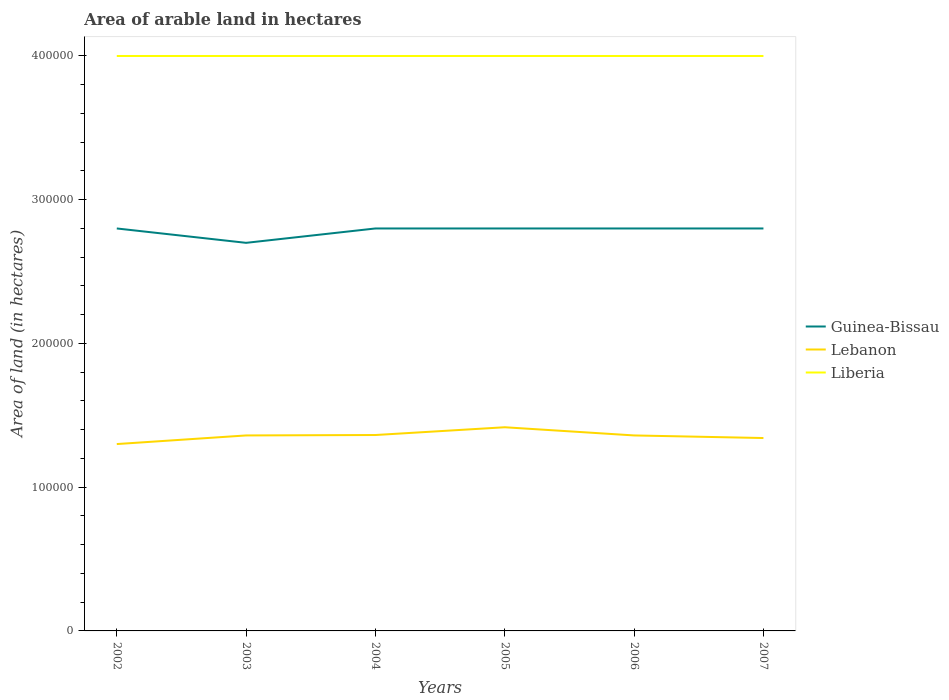How many different coloured lines are there?
Give a very brief answer. 3. Does the line corresponding to Lebanon intersect with the line corresponding to Liberia?
Make the answer very short. No. Across all years, what is the maximum total arable land in Lebanon?
Provide a succinct answer. 1.30e+05. What is the total total arable land in Lebanon in the graph?
Your answer should be very brief. -300. What is the difference between the highest and the second highest total arable land in Lebanon?
Your response must be concise. 1.17e+04. Where does the legend appear in the graph?
Ensure brevity in your answer.  Center right. What is the title of the graph?
Give a very brief answer. Area of arable land in hectares. What is the label or title of the Y-axis?
Provide a succinct answer. Area of land (in hectares). What is the Area of land (in hectares) in Guinea-Bissau in 2002?
Provide a short and direct response. 2.80e+05. What is the Area of land (in hectares) of Lebanon in 2002?
Provide a short and direct response. 1.30e+05. What is the Area of land (in hectares) of Lebanon in 2003?
Offer a terse response. 1.36e+05. What is the Area of land (in hectares) in Lebanon in 2004?
Your response must be concise. 1.36e+05. What is the Area of land (in hectares) in Guinea-Bissau in 2005?
Provide a short and direct response. 2.80e+05. What is the Area of land (in hectares) in Lebanon in 2005?
Provide a succinct answer. 1.42e+05. What is the Area of land (in hectares) of Liberia in 2005?
Offer a very short reply. 4.00e+05. What is the Area of land (in hectares) of Guinea-Bissau in 2006?
Make the answer very short. 2.80e+05. What is the Area of land (in hectares) in Lebanon in 2006?
Your answer should be compact. 1.36e+05. What is the Area of land (in hectares) in Lebanon in 2007?
Your answer should be compact. 1.34e+05. Across all years, what is the maximum Area of land (in hectares) of Lebanon?
Your response must be concise. 1.42e+05. Across all years, what is the maximum Area of land (in hectares) of Liberia?
Your answer should be very brief. 4.00e+05. Across all years, what is the minimum Area of land (in hectares) in Lebanon?
Give a very brief answer. 1.30e+05. What is the total Area of land (in hectares) of Guinea-Bissau in the graph?
Your answer should be very brief. 1.67e+06. What is the total Area of land (in hectares) in Lebanon in the graph?
Ensure brevity in your answer.  8.14e+05. What is the total Area of land (in hectares) of Liberia in the graph?
Provide a short and direct response. 2.40e+06. What is the difference between the Area of land (in hectares) of Guinea-Bissau in 2002 and that in 2003?
Your answer should be compact. 10000. What is the difference between the Area of land (in hectares) in Lebanon in 2002 and that in 2003?
Make the answer very short. -6000. What is the difference between the Area of land (in hectares) of Lebanon in 2002 and that in 2004?
Your response must be concise. -6300. What is the difference between the Area of land (in hectares) of Lebanon in 2002 and that in 2005?
Your answer should be very brief. -1.17e+04. What is the difference between the Area of land (in hectares) in Guinea-Bissau in 2002 and that in 2006?
Offer a terse response. 0. What is the difference between the Area of land (in hectares) in Lebanon in 2002 and that in 2006?
Your response must be concise. -6000. What is the difference between the Area of land (in hectares) in Guinea-Bissau in 2002 and that in 2007?
Your answer should be compact. 0. What is the difference between the Area of land (in hectares) in Lebanon in 2002 and that in 2007?
Provide a succinct answer. -4200. What is the difference between the Area of land (in hectares) in Liberia in 2002 and that in 2007?
Provide a short and direct response. 0. What is the difference between the Area of land (in hectares) of Guinea-Bissau in 2003 and that in 2004?
Make the answer very short. -10000. What is the difference between the Area of land (in hectares) of Lebanon in 2003 and that in 2004?
Your answer should be very brief. -300. What is the difference between the Area of land (in hectares) of Guinea-Bissau in 2003 and that in 2005?
Your answer should be very brief. -10000. What is the difference between the Area of land (in hectares) in Lebanon in 2003 and that in 2005?
Ensure brevity in your answer.  -5700. What is the difference between the Area of land (in hectares) in Liberia in 2003 and that in 2005?
Provide a short and direct response. 0. What is the difference between the Area of land (in hectares) of Lebanon in 2003 and that in 2007?
Give a very brief answer. 1800. What is the difference between the Area of land (in hectares) of Lebanon in 2004 and that in 2005?
Provide a succinct answer. -5400. What is the difference between the Area of land (in hectares) in Guinea-Bissau in 2004 and that in 2006?
Provide a succinct answer. 0. What is the difference between the Area of land (in hectares) in Lebanon in 2004 and that in 2006?
Your answer should be very brief. 300. What is the difference between the Area of land (in hectares) in Liberia in 2004 and that in 2006?
Keep it short and to the point. 0. What is the difference between the Area of land (in hectares) in Lebanon in 2004 and that in 2007?
Provide a short and direct response. 2100. What is the difference between the Area of land (in hectares) of Liberia in 2004 and that in 2007?
Your answer should be compact. 0. What is the difference between the Area of land (in hectares) in Guinea-Bissau in 2005 and that in 2006?
Offer a very short reply. 0. What is the difference between the Area of land (in hectares) in Lebanon in 2005 and that in 2006?
Keep it short and to the point. 5700. What is the difference between the Area of land (in hectares) in Liberia in 2005 and that in 2006?
Give a very brief answer. 0. What is the difference between the Area of land (in hectares) in Lebanon in 2005 and that in 2007?
Ensure brevity in your answer.  7500. What is the difference between the Area of land (in hectares) in Liberia in 2005 and that in 2007?
Your answer should be very brief. 0. What is the difference between the Area of land (in hectares) of Guinea-Bissau in 2006 and that in 2007?
Keep it short and to the point. 0. What is the difference between the Area of land (in hectares) of Lebanon in 2006 and that in 2007?
Provide a short and direct response. 1800. What is the difference between the Area of land (in hectares) in Guinea-Bissau in 2002 and the Area of land (in hectares) in Lebanon in 2003?
Your answer should be very brief. 1.44e+05. What is the difference between the Area of land (in hectares) in Guinea-Bissau in 2002 and the Area of land (in hectares) in Lebanon in 2004?
Your answer should be very brief. 1.44e+05. What is the difference between the Area of land (in hectares) of Guinea-Bissau in 2002 and the Area of land (in hectares) of Liberia in 2004?
Give a very brief answer. -1.20e+05. What is the difference between the Area of land (in hectares) of Guinea-Bissau in 2002 and the Area of land (in hectares) of Lebanon in 2005?
Your response must be concise. 1.38e+05. What is the difference between the Area of land (in hectares) of Lebanon in 2002 and the Area of land (in hectares) of Liberia in 2005?
Keep it short and to the point. -2.70e+05. What is the difference between the Area of land (in hectares) of Guinea-Bissau in 2002 and the Area of land (in hectares) of Lebanon in 2006?
Keep it short and to the point. 1.44e+05. What is the difference between the Area of land (in hectares) in Lebanon in 2002 and the Area of land (in hectares) in Liberia in 2006?
Your answer should be compact. -2.70e+05. What is the difference between the Area of land (in hectares) in Guinea-Bissau in 2002 and the Area of land (in hectares) in Lebanon in 2007?
Offer a terse response. 1.46e+05. What is the difference between the Area of land (in hectares) of Lebanon in 2002 and the Area of land (in hectares) of Liberia in 2007?
Your answer should be very brief. -2.70e+05. What is the difference between the Area of land (in hectares) of Guinea-Bissau in 2003 and the Area of land (in hectares) of Lebanon in 2004?
Your answer should be very brief. 1.34e+05. What is the difference between the Area of land (in hectares) of Guinea-Bissau in 2003 and the Area of land (in hectares) of Liberia in 2004?
Ensure brevity in your answer.  -1.30e+05. What is the difference between the Area of land (in hectares) of Lebanon in 2003 and the Area of land (in hectares) of Liberia in 2004?
Your answer should be very brief. -2.64e+05. What is the difference between the Area of land (in hectares) in Guinea-Bissau in 2003 and the Area of land (in hectares) in Lebanon in 2005?
Give a very brief answer. 1.28e+05. What is the difference between the Area of land (in hectares) of Lebanon in 2003 and the Area of land (in hectares) of Liberia in 2005?
Provide a short and direct response. -2.64e+05. What is the difference between the Area of land (in hectares) in Guinea-Bissau in 2003 and the Area of land (in hectares) in Lebanon in 2006?
Your response must be concise. 1.34e+05. What is the difference between the Area of land (in hectares) in Guinea-Bissau in 2003 and the Area of land (in hectares) in Liberia in 2006?
Your answer should be compact. -1.30e+05. What is the difference between the Area of land (in hectares) of Lebanon in 2003 and the Area of land (in hectares) of Liberia in 2006?
Keep it short and to the point. -2.64e+05. What is the difference between the Area of land (in hectares) of Guinea-Bissau in 2003 and the Area of land (in hectares) of Lebanon in 2007?
Your response must be concise. 1.36e+05. What is the difference between the Area of land (in hectares) of Guinea-Bissau in 2003 and the Area of land (in hectares) of Liberia in 2007?
Offer a terse response. -1.30e+05. What is the difference between the Area of land (in hectares) in Lebanon in 2003 and the Area of land (in hectares) in Liberia in 2007?
Your answer should be compact. -2.64e+05. What is the difference between the Area of land (in hectares) of Guinea-Bissau in 2004 and the Area of land (in hectares) of Lebanon in 2005?
Your response must be concise. 1.38e+05. What is the difference between the Area of land (in hectares) of Guinea-Bissau in 2004 and the Area of land (in hectares) of Liberia in 2005?
Provide a succinct answer. -1.20e+05. What is the difference between the Area of land (in hectares) in Lebanon in 2004 and the Area of land (in hectares) in Liberia in 2005?
Your response must be concise. -2.64e+05. What is the difference between the Area of land (in hectares) of Guinea-Bissau in 2004 and the Area of land (in hectares) of Lebanon in 2006?
Your answer should be compact. 1.44e+05. What is the difference between the Area of land (in hectares) in Lebanon in 2004 and the Area of land (in hectares) in Liberia in 2006?
Offer a terse response. -2.64e+05. What is the difference between the Area of land (in hectares) of Guinea-Bissau in 2004 and the Area of land (in hectares) of Lebanon in 2007?
Provide a short and direct response. 1.46e+05. What is the difference between the Area of land (in hectares) in Lebanon in 2004 and the Area of land (in hectares) in Liberia in 2007?
Your answer should be compact. -2.64e+05. What is the difference between the Area of land (in hectares) in Guinea-Bissau in 2005 and the Area of land (in hectares) in Lebanon in 2006?
Offer a very short reply. 1.44e+05. What is the difference between the Area of land (in hectares) of Guinea-Bissau in 2005 and the Area of land (in hectares) of Liberia in 2006?
Provide a succinct answer. -1.20e+05. What is the difference between the Area of land (in hectares) of Lebanon in 2005 and the Area of land (in hectares) of Liberia in 2006?
Your answer should be compact. -2.58e+05. What is the difference between the Area of land (in hectares) in Guinea-Bissau in 2005 and the Area of land (in hectares) in Lebanon in 2007?
Make the answer very short. 1.46e+05. What is the difference between the Area of land (in hectares) of Lebanon in 2005 and the Area of land (in hectares) of Liberia in 2007?
Give a very brief answer. -2.58e+05. What is the difference between the Area of land (in hectares) of Guinea-Bissau in 2006 and the Area of land (in hectares) of Lebanon in 2007?
Ensure brevity in your answer.  1.46e+05. What is the difference between the Area of land (in hectares) in Lebanon in 2006 and the Area of land (in hectares) in Liberia in 2007?
Your answer should be very brief. -2.64e+05. What is the average Area of land (in hectares) of Guinea-Bissau per year?
Provide a succinct answer. 2.78e+05. What is the average Area of land (in hectares) in Lebanon per year?
Provide a succinct answer. 1.36e+05. What is the average Area of land (in hectares) in Liberia per year?
Make the answer very short. 4.00e+05. In the year 2002, what is the difference between the Area of land (in hectares) of Guinea-Bissau and Area of land (in hectares) of Lebanon?
Make the answer very short. 1.50e+05. In the year 2003, what is the difference between the Area of land (in hectares) of Guinea-Bissau and Area of land (in hectares) of Lebanon?
Make the answer very short. 1.34e+05. In the year 2003, what is the difference between the Area of land (in hectares) of Lebanon and Area of land (in hectares) of Liberia?
Provide a short and direct response. -2.64e+05. In the year 2004, what is the difference between the Area of land (in hectares) in Guinea-Bissau and Area of land (in hectares) in Lebanon?
Your answer should be compact. 1.44e+05. In the year 2004, what is the difference between the Area of land (in hectares) of Lebanon and Area of land (in hectares) of Liberia?
Offer a very short reply. -2.64e+05. In the year 2005, what is the difference between the Area of land (in hectares) in Guinea-Bissau and Area of land (in hectares) in Lebanon?
Your answer should be compact. 1.38e+05. In the year 2005, what is the difference between the Area of land (in hectares) in Guinea-Bissau and Area of land (in hectares) in Liberia?
Make the answer very short. -1.20e+05. In the year 2005, what is the difference between the Area of land (in hectares) of Lebanon and Area of land (in hectares) of Liberia?
Offer a very short reply. -2.58e+05. In the year 2006, what is the difference between the Area of land (in hectares) in Guinea-Bissau and Area of land (in hectares) in Lebanon?
Keep it short and to the point. 1.44e+05. In the year 2006, what is the difference between the Area of land (in hectares) of Lebanon and Area of land (in hectares) of Liberia?
Provide a short and direct response. -2.64e+05. In the year 2007, what is the difference between the Area of land (in hectares) of Guinea-Bissau and Area of land (in hectares) of Lebanon?
Offer a terse response. 1.46e+05. In the year 2007, what is the difference between the Area of land (in hectares) in Lebanon and Area of land (in hectares) in Liberia?
Your answer should be very brief. -2.66e+05. What is the ratio of the Area of land (in hectares) of Lebanon in 2002 to that in 2003?
Ensure brevity in your answer.  0.96. What is the ratio of the Area of land (in hectares) in Liberia in 2002 to that in 2003?
Provide a short and direct response. 1. What is the ratio of the Area of land (in hectares) of Lebanon in 2002 to that in 2004?
Your answer should be very brief. 0.95. What is the ratio of the Area of land (in hectares) of Liberia in 2002 to that in 2004?
Provide a short and direct response. 1. What is the ratio of the Area of land (in hectares) of Guinea-Bissau in 2002 to that in 2005?
Your answer should be very brief. 1. What is the ratio of the Area of land (in hectares) of Lebanon in 2002 to that in 2005?
Your response must be concise. 0.92. What is the ratio of the Area of land (in hectares) in Liberia in 2002 to that in 2005?
Provide a short and direct response. 1. What is the ratio of the Area of land (in hectares) of Guinea-Bissau in 2002 to that in 2006?
Provide a short and direct response. 1. What is the ratio of the Area of land (in hectares) in Lebanon in 2002 to that in 2006?
Ensure brevity in your answer.  0.96. What is the ratio of the Area of land (in hectares) in Guinea-Bissau in 2002 to that in 2007?
Provide a succinct answer. 1. What is the ratio of the Area of land (in hectares) in Lebanon in 2002 to that in 2007?
Provide a short and direct response. 0.97. What is the ratio of the Area of land (in hectares) of Guinea-Bissau in 2003 to that in 2004?
Provide a short and direct response. 0.96. What is the ratio of the Area of land (in hectares) in Guinea-Bissau in 2003 to that in 2005?
Make the answer very short. 0.96. What is the ratio of the Area of land (in hectares) in Lebanon in 2003 to that in 2005?
Your answer should be very brief. 0.96. What is the ratio of the Area of land (in hectares) of Guinea-Bissau in 2003 to that in 2007?
Ensure brevity in your answer.  0.96. What is the ratio of the Area of land (in hectares) of Lebanon in 2003 to that in 2007?
Provide a short and direct response. 1.01. What is the ratio of the Area of land (in hectares) in Lebanon in 2004 to that in 2005?
Offer a very short reply. 0.96. What is the ratio of the Area of land (in hectares) of Liberia in 2004 to that in 2005?
Offer a very short reply. 1. What is the ratio of the Area of land (in hectares) in Guinea-Bissau in 2004 to that in 2006?
Your answer should be compact. 1. What is the ratio of the Area of land (in hectares) of Lebanon in 2004 to that in 2006?
Your answer should be very brief. 1. What is the ratio of the Area of land (in hectares) of Liberia in 2004 to that in 2006?
Your response must be concise. 1. What is the ratio of the Area of land (in hectares) in Lebanon in 2004 to that in 2007?
Your answer should be very brief. 1.02. What is the ratio of the Area of land (in hectares) in Liberia in 2004 to that in 2007?
Ensure brevity in your answer.  1. What is the ratio of the Area of land (in hectares) of Lebanon in 2005 to that in 2006?
Provide a short and direct response. 1.04. What is the ratio of the Area of land (in hectares) of Guinea-Bissau in 2005 to that in 2007?
Give a very brief answer. 1. What is the ratio of the Area of land (in hectares) of Lebanon in 2005 to that in 2007?
Make the answer very short. 1.06. What is the ratio of the Area of land (in hectares) of Liberia in 2005 to that in 2007?
Give a very brief answer. 1. What is the ratio of the Area of land (in hectares) in Lebanon in 2006 to that in 2007?
Provide a succinct answer. 1.01. What is the ratio of the Area of land (in hectares) in Liberia in 2006 to that in 2007?
Give a very brief answer. 1. What is the difference between the highest and the second highest Area of land (in hectares) of Guinea-Bissau?
Your response must be concise. 0. What is the difference between the highest and the second highest Area of land (in hectares) of Lebanon?
Your answer should be compact. 5400. What is the difference between the highest and the second highest Area of land (in hectares) of Liberia?
Offer a very short reply. 0. What is the difference between the highest and the lowest Area of land (in hectares) in Guinea-Bissau?
Provide a short and direct response. 10000. What is the difference between the highest and the lowest Area of land (in hectares) of Lebanon?
Your answer should be compact. 1.17e+04. 